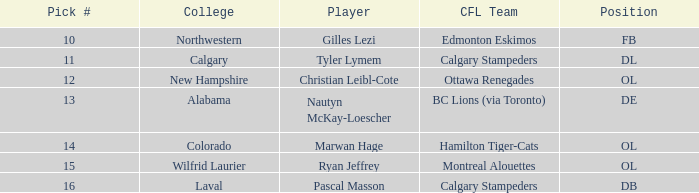What is the pick number for Northwestern college? 10.0. 